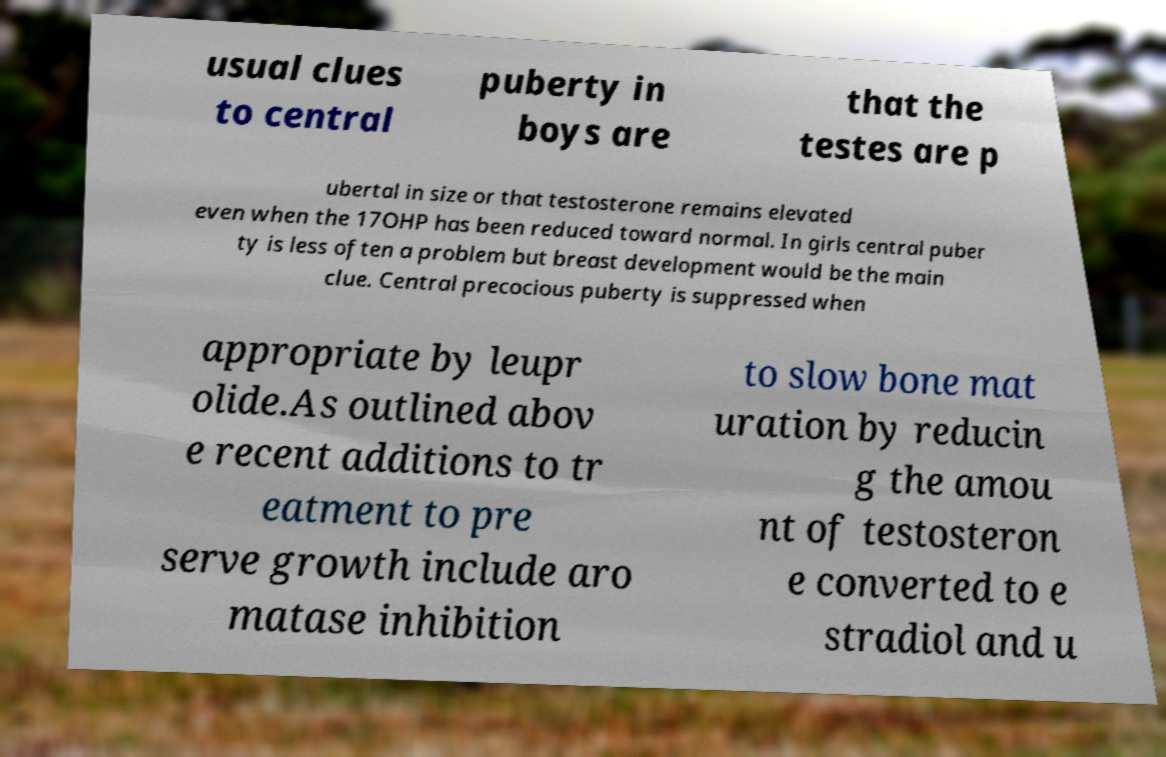Can you read and provide the text displayed in the image?This photo seems to have some interesting text. Can you extract and type it out for me? usual clues to central puberty in boys are that the testes are p ubertal in size or that testosterone remains elevated even when the 17OHP has been reduced toward normal. In girls central puber ty is less often a problem but breast development would be the main clue. Central precocious puberty is suppressed when appropriate by leupr olide.As outlined abov e recent additions to tr eatment to pre serve growth include aro matase inhibition to slow bone mat uration by reducin g the amou nt of testosteron e converted to e stradiol and u 